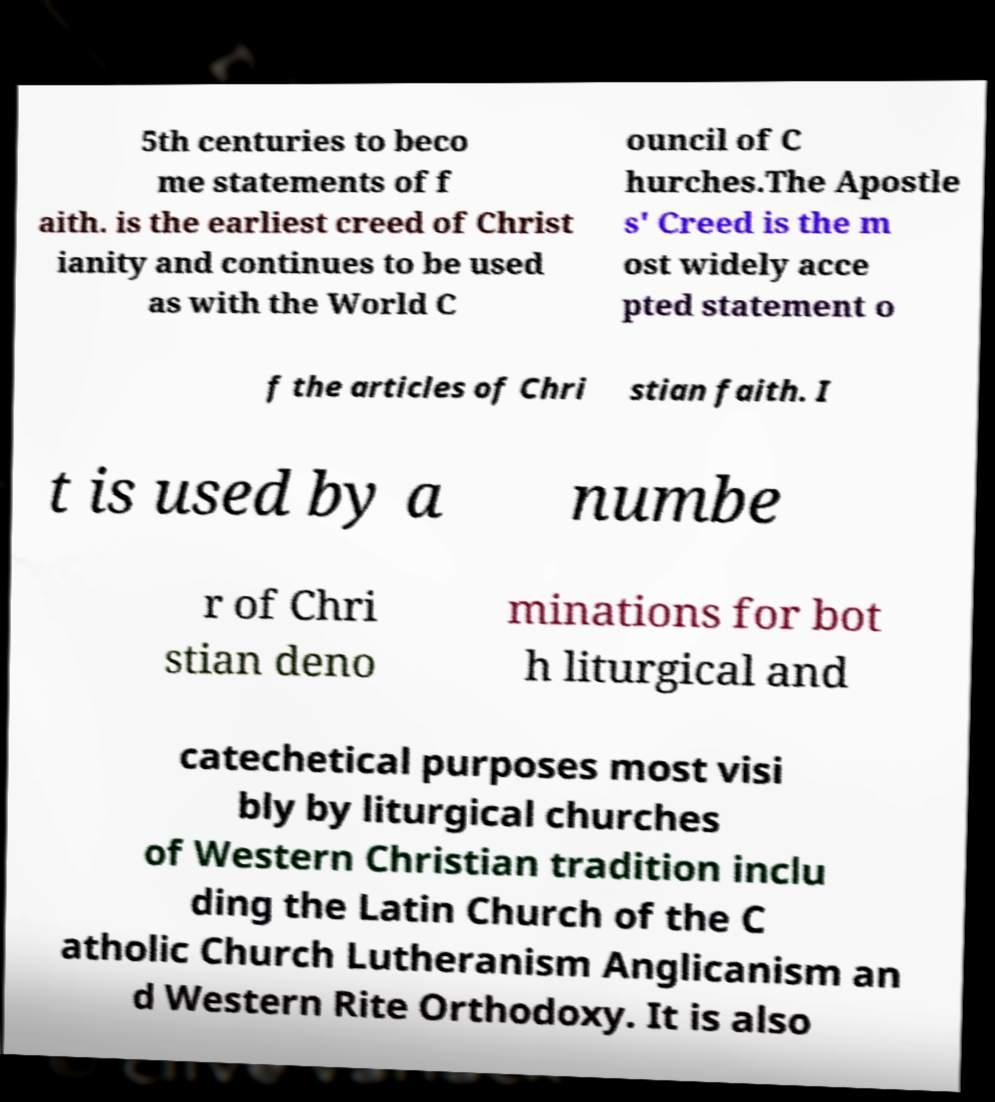For documentation purposes, I need the text within this image transcribed. Could you provide that? 5th centuries to beco me statements of f aith. is the earliest creed of Christ ianity and continues to be used as with the World C ouncil of C hurches.The Apostle s' Creed is the m ost widely acce pted statement o f the articles of Chri stian faith. I t is used by a numbe r of Chri stian deno minations for bot h liturgical and catechetical purposes most visi bly by liturgical churches of Western Christian tradition inclu ding the Latin Church of the C atholic Church Lutheranism Anglicanism an d Western Rite Orthodoxy. It is also 